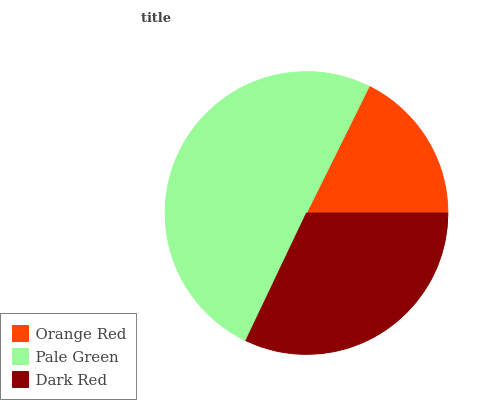Is Orange Red the minimum?
Answer yes or no. Yes. Is Pale Green the maximum?
Answer yes or no. Yes. Is Dark Red the minimum?
Answer yes or no. No. Is Dark Red the maximum?
Answer yes or no. No. Is Pale Green greater than Dark Red?
Answer yes or no. Yes. Is Dark Red less than Pale Green?
Answer yes or no. Yes. Is Dark Red greater than Pale Green?
Answer yes or no. No. Is Pale Green less than Dark Red?
Answer yes or no. No. Is Dark Red the high median?
Answer yes or no. Yes. Is Dark Red the low median?
Answer yes or no. Yes. Is Orange Red the high median?
Answer yes or no. No. Is Orange Red the low median?
Answer yes or no. No. 